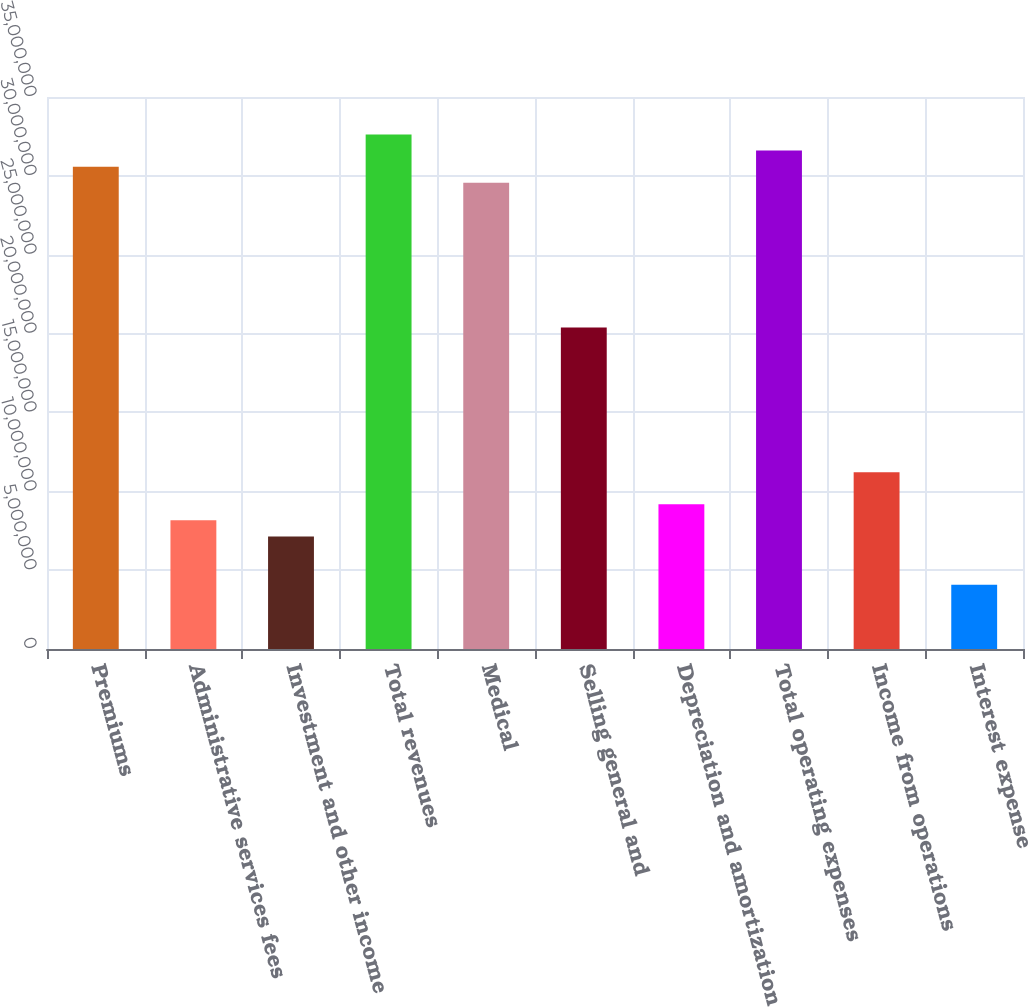Convert chart. <chart><loc_0><loc_0><loc_500><loc_500><bar_chart><fcel>Premiums<fcel>Administrative services fees<fcel>Investment and other income<fcel>Total revenues<fcel>Medical<fcel>Selling general and<fcel>Depreciation and amortization<fcel>Total operating expenses<fcel>Income from operations<fcel>Interest expense<nl><fcel>3.05847e+07<fcel>8.15591e+06<fcel>7.13642e+06<fcel>3.26236e+07<fcel>2.95652e+07<fcel>2.03898e+07<fcel>9.1754e+06<fcel>3.16041e+07<fcel>1.12144e+07<fcel>4.07795e+06<nl></chart> 